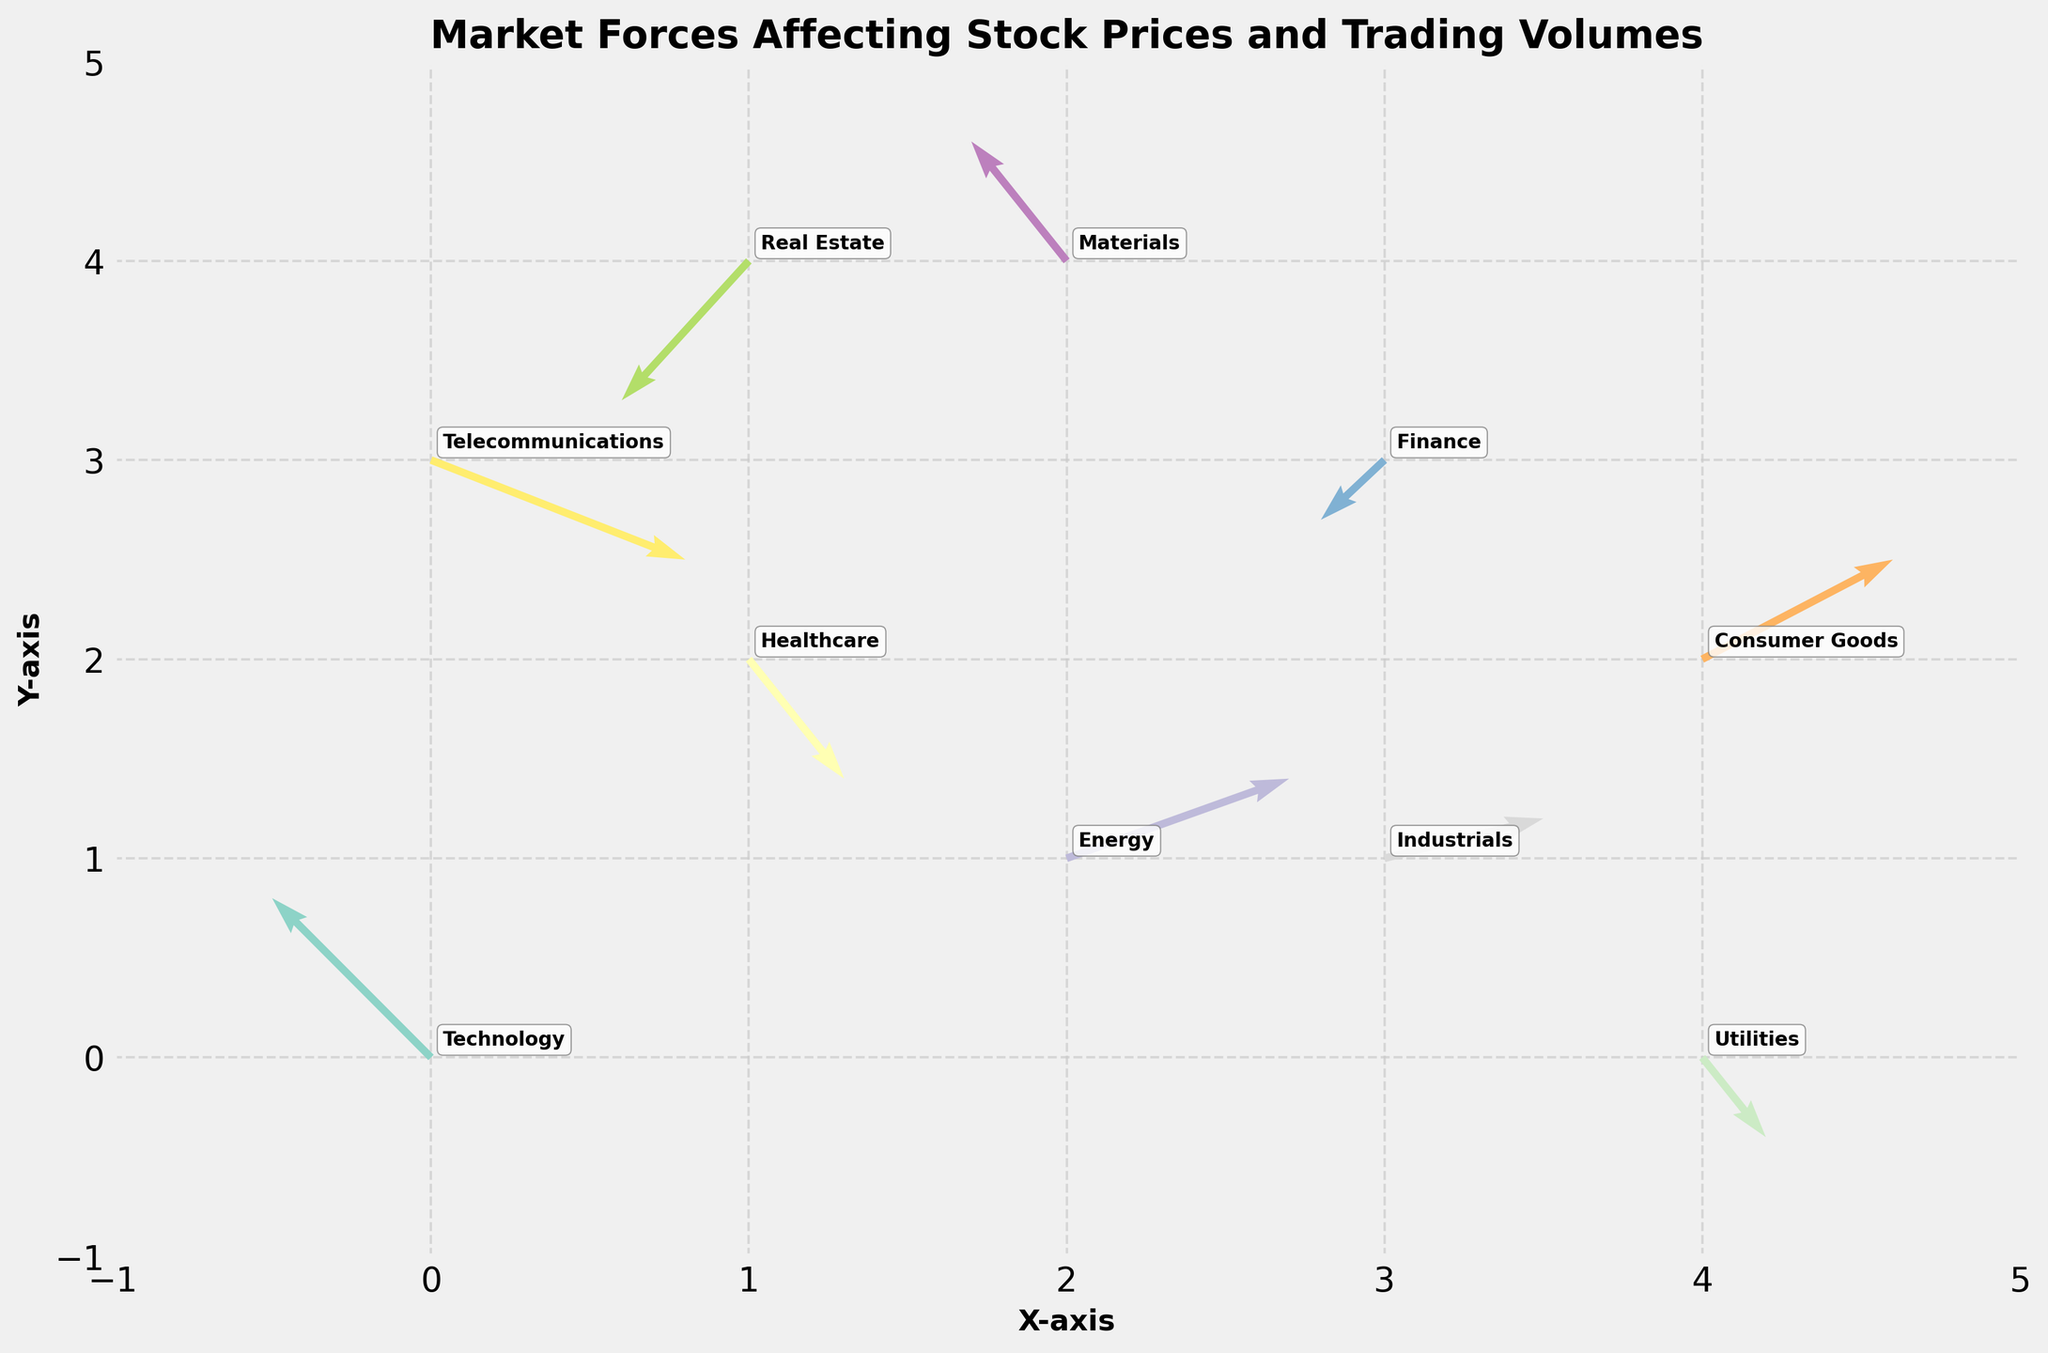What's the title of the figure? The title can be found at the top of the figure, which is usually in larger and bold font. In this case, the title specified in the code is "Market Forces Affecting Stock Prices and Trading Volumes".
Answer: Market Forces Affecting Stock Prices and Trading Volumes What are the x and y-axis labels? The axes labels are usually found adjacent to the axes. In this case, they are set in the code as 'X-axis' for the x-axis and 'Y-axis' for the y-axis.
Answer: X-axis, Y-axis How many sectors are represented in the figure? Each sector is labeled with its name in the plot. By counting the distinct labels, we determine the number of sectors.
Answer: 10 Which sector has the most positive x-direction force? By looking at the length and direction of the arrows (u values) for each sector, the sector with the longest arrow pointing right (positive u value) is the one with the most positive x-direction force. This is the 'Telecommunications' sector.
Answer: Telecommunications Which sector's force is directed most negatively in the y-direction? By examining the arrows pointing downward (negative v values) for each sector, the sector with the most prominent y-direction negative force is indicated. Here, 'Real Estate' has the largest downward arrow.
Answer: Real Estate Which sectors have forces directed positively in both x and y directions? Sectors with forces in the positive x and y directions have arrows pointing up and to the right. By examining these, we find the 'Energy' and 'Consumer Goods' sectors.
Answer: Energy, Consumer Goods Compare the total directional forces of the sectors 'Healthcare' and 'Finance'. Which sector has a higher resultant force? We calculate the resultant force using the Pythagorean theorem: √(u² + v²).
- Healthcare: u=0.3, v=-0.6, Resultant = √(0.3² + (-0.6)²) = √(0.09 + 0.36) = √0.45 ≈ 0.67
- Finance: u=-0.2, v=-0.3, Resultant = √((-0.2)² + (-0.3)²) = √(0.04 + 0.09) = √0.13 ≈ 0.36
Thus, Healthcare has a higher resultant force.
Answer: Healthcare What is the average x-direction force (u values) across all sectors? We sum up the x-direction forces (u values) and divide by the number of sectors.
Sum of u values = -0.5 + 0.3 + 0.7 -0.2 + 0.6 -0.4 + 0.5 -0.3 + 0.2 + 0.8 = 1.7
Number of sectors = 10
Average = 1.7 / 10 = 0.17
Answer: 0.17 Which sector has the lowest resultant force? Calculate the resultant force for each sector using √(u² + v²) and find the smallest.
- Technology: √((-0.5)² + 0.8²) = √(0.25 + 0.64) = √0.89 ≈ 0.94
- Healthcare: √(0.3² + (-0.6)²) = √(0.09 + 0.36) = √0.45 ≈ 0.67
- Energy: √(0.7² + 0.4²) = √(0.49 + 0.16) = √0.65 ≈ 0.81
- Finance: √((-0.2)² + (-0.3)²) = √(0.04 + 0.09) = √0.13 ≈ 0.36
- Consumer Goods: √(0.6² + 0.5²) = √(0.36 + 0.25) = √0.61 ≈ 0.78
- Real Estate: √((-0.4)² + (-0.7)²) = √(0.16 + 0.49) = √0.65 ≈ 0.81
- Industrials: √(0.5² + 0.2²) = √(0.25 + 0.04) = √0.29 ≈ 0.54
- Materials: √((-0.3)² + 0.6²) = √(0.09 + 0.36) = √0.45 ≈ 0.67
- Utilities: √(0.2² + (-0.4)²) = √(0.04 + 0.16) = √0.20 ≈ 0.45
- Telecommunications: √(0.8² + (-0.5)²) = √(0.64 + 0.25) = √0.89 ≈ 0.94
The sector with the lowest resultant force is 'Finance'.
Answer: Finance 